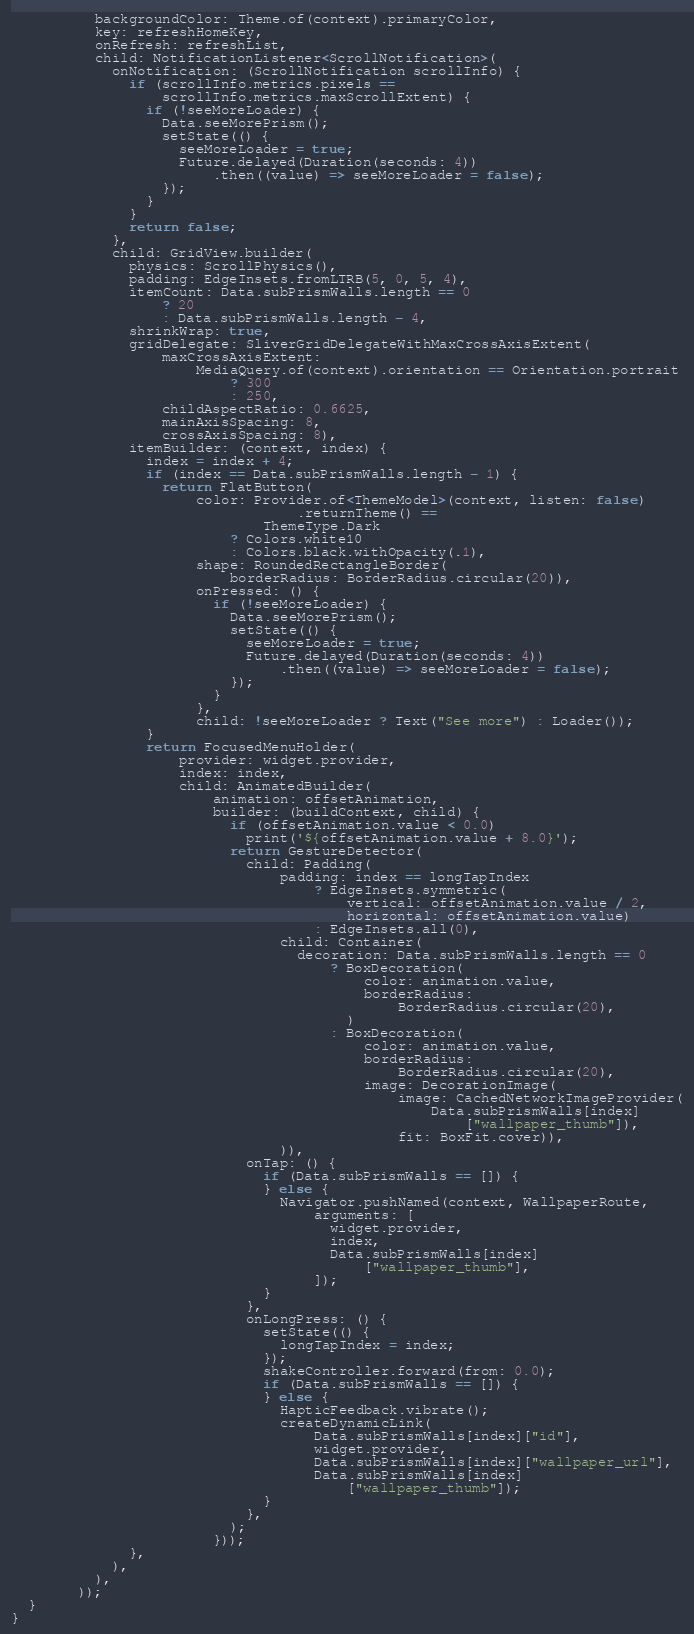Convert code to text. <code><loc_0><loc_0><loc_500><loc_500><_Dart_>          backgroundColor: Theme.of(context).primaryColor,
          key: refreshHomeKey,
          onRefresh: refreshList,
          child: NotificationListener<ScrollNotification>(
            onNotification: (ScrollNotification scrollInfo) {
              if (scrollInfo.metrics.pixels ==
                  scrollInfo.metrics.maxScrollExtent) {
                if (!seeMoreLoader) {
                  Data.seeMorePrism();
                  setState(() {
                    seeMoreLoader = true;
                    Future.delayed(Duration(seconds: 4))
                        .then((value) => seeMoreLoader = false);
                  });
                }
              }
              return false;
            },
            child: GridView.builder(
              physics: ScrollPhysics(),
              padding: EdgeInsets.fromLTRB(5, 0, 5, 4),
              itemCount: Data.subPrismWalls.length == 0
                  ? 20
                  : Data.subPrismWalls.length - 4,
              shrinkWrap: true,
              gridDelegate: SliverGridDelegateWithMaxCrossAxisExtent(
                  maxCrossAxisExtent:
                      MediaQuery.of(context).orientation == Orientation.portrait
                          ? 300
                          : 250,
                  childAspectRatio: 0.6625,
                  mainAxisSpacing: 8,
                  crossAxisSpacing: 8),
              itemBuilder: (context, index) {
                index = index + 4;
                if (index == Data.subPrismWalls.length - 1) {
                  return FlatButton(
                      color: Provider.of<ThemeModel>(context, listen: false)
                                  .returnTheme() ==
                              ThemeType.Dark
                          ? Colors.white10
                          : Colors.black.withOpacity(.1),
                      shape: RoundedRectangleBorder(
                          borderRadius: BorderRadius.circular(20)),
                      onPressed: () {
                        if (!seeMoreLoader) {
                          Data.seeMorePrism();
                          setState(() {
                            seeMoreLoader = true;
                            Future.delayed(Duration(seconds: 4))
                                .then((value) => seeMoreLoader = false);
                          });
                        }
                      },
                      child: !seeMoreLoader ? Text("See more") : Loader());
                }
                return FocusedMenuHolder(
                    provider: widget.provider,
                    index: index,
                    child: AnimatedBuilder(
                        animation: offsetAnimation,
                        builder: (buildContext, child) {
                          if (offsetAnimation.value < 0.0)
                            print('${offsetAnimation.value + 8.0}');
                          return GestureDetector(
                            child: Padding(
                                padding: index == longTapIndex
                                    ? EdgeInsets.symmetric(
                                        vertical: offsetAnimation.value / 2,
                                        horizontal: offsetAnimation.value)
                                    : EdgeInsets.all(0),
                                child: Container(
                                  decoration: Data.subPrismWalls.length == 0
                                      ? BoxDecoration(
                                          color: animation.value,
                                          borderRadius:
                                              BorderRadius.circular(20),
                                        )
                                      : BoxDecoration(
                                          color: animation.value,
                                          borderRadius:
                                              BorderRadius.circular(20),
                                          image: DecorationImage(
                                              image: CachedNetworkImageProvider(
                                                  Data.subPrismWalls[index]
                                                      ["wallpaper_thumb"]),
                                              fit: BoxFit.cover)),
                                )),
                            onTap: () {
                              if (Data.subPrismWalls == []) {
                              } else {
                                Navigator.pushNamed(context, WallpaperRoute,
                                    arguments: [
                                      widget.provider,
                                      index,
                                      Data.subPrismWalls[index]
                                          ["wallpaper_thumb"],
                                    ]);
                              }
                            },
                            onLongPress: () {
                              setState(() {
                                longTapIndex = index;
                              });
                              shakeController.forward(from: 0.0);
                              if (Data.subPrismWalls == []) {
                              } else {
                                HapticFeedback.vibrate();
                                createDynamicLink(
                                    Data.subPrismWalls[index]["id"],
                                    widget.provider,
                                    Data.subPrismWalls[index]["wallpaper_url"],
                                    Data.subPrismWalls[index]
                                        ["wallpaper_thumb"]);
                              }
                            },
                          );
                        }));
              },
            ),
          ),
        ));
  }
}
</code> 